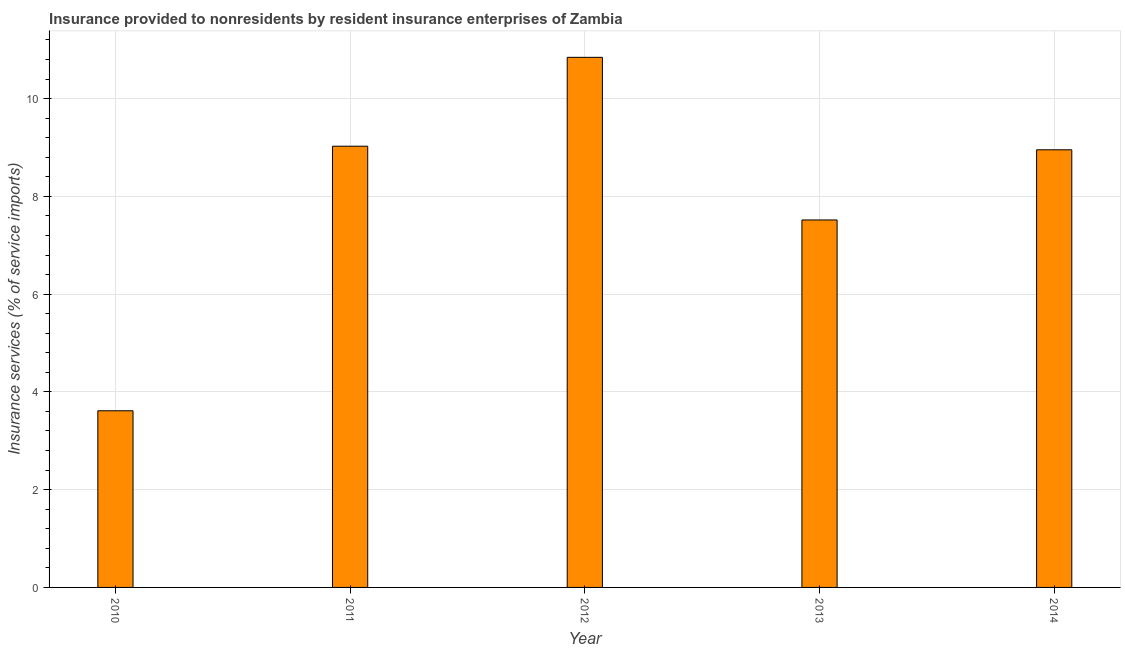Does the graph contain any zero values?
Your answer should be compact. No. Does the graph contain grids?
Ensure brevity in your answer.  Yes. What is the title of the graph?
Ensure brevity in your answer.  Insurance provided to nonresidents by resident insurance enterprises of Zambia. What is the label or title of the Y-axis?
Keep it short and to the point. Insurance services (% of service imports). What is the insurance and financial services in 2014?
Offer a very short reply. 8.95. Across all years, what is the maximum insurance and financial services?
Provide a short and direct response. 10.84. Across all years, what is the minimum insurance and financial services?
Offer a terse response. 3.61. In which year was the insurance and financial services maximum?
Keep it short and to the point. 2012. In which year was the insurance and financial services minimum?
Give a very brief answer. 2010. What is the sum of the insurance and financial services?
Your answer should be compact. 39.95. What is the difference between the insurance and financial services in 2012 and 2014?
Offer a terse response. 1.89. What is the average insurance and financial services per year?
Your response must be concise. 7.99. What is the median insurance and financial services?
Provide a succinct answer. 8.95. In how many years, is the insurance and financial services greater than 0.8 %?
Your answer should be very brief. 5. What is the ratio of the insurance and financial services in 2010 to that in 2011?
Your answer should be compact. 0.4. Is the insurance and financial services in 2010 less than that in 2014?
Offer a terse response. Yes. What is the difference between the highest and the second highest insurance and financial services?
Provide a succinct answer. 1.82. What is the difference between the highest and the lowest insurance and financial services?
Provide a succinct answer. 7.23. How many bars are there?
Your answer should be very brief. 5. Are all the bars in the graph horizontal?
Give a very brief answer. No. What is the Insurance services (% of service imports) in 2010?
Ensure brevity in your answer.  3.61. What is the Insurance services (% of service imports) of 2011?
Make the answer very short. 9.03. What is the Insurance services (% of service imports) in 2012?
Offer a very short reply. 10.84. What is the Insurance services (% of service imports) in 2013?
Offer a terse response. 7.52. What is the Insurance services (% of service imports) in 2014?
Your response must be concise. 8.95. What is the difference between the Insurance services (% of service imports) in 2010 and 2011?
Keep it short and to the point. -5.41. What is the difference between the Insurance services (% of service imports) in 2010 and 2012?
Offer a very short reply. -7.23. What is the difference between the Insurance services (% of service imports) in 2010 and 2013?
Offer a terse response. -3.9. What is the difference between the Insurance services (% of service imports) in 2010 and 2014?
Ensure brevity in your answer.  -5.34. What is the difference between the Insurance services (% of service imports) in 2011 and 2012?
Provide a short and direct response. -1.82. What is the difference between the Insurance services (% of service imports) in 2011 and 2013?
Keep it short and to the point. 1.51. What is the difference between the Insurance services (% of service imports) in 2011 and 2014?
Your response must be concise. 0.07. What is the difference between the Insurance services (% of service imports) in 2012 and 2013?
Make the answer very short. 3.33. What is the difference between the Insurance services (% of service imports) in 2012 and 2014?
Provide a short and direct response. 1.89. What is the difference between the Insurance services (% of service imports) in 2013 and 2014?
Ensure brevity in your answer.  -1.44. What is the ratio of the Insurance services (% of service imports) in 2010 to that in 2011?
Ensure brevity in your answer.  0.4. What is the ratio of the Insurance services (% of service imports) in 2010 to that in 2012?
Your answer should be compact. 0.33. What is the ratio of the Insurance services (% of service imports) in 2010 to that in 2013?
Your answer should be compact. 0.48. What is the ratio of the Insurance services (% of service imports) in 2010 to that in 2014?
Keep it short and to the point. 0.4. What is the ratio of the Insurance services (% of service imports) in 2011 to that in 2012?
Your response must be concise. 0.83. What is the ratio of the Insurance services (% of service imports) in 2011 to that in 2013?
Your response must be concise. 1.2. What is the ratio of the Insurance services (% of service imports) in 2011 to that in 2014?
Provide a succinct answer. 1.01. What is the ratio of the Insurance services (% of service imports) in 2012 to that in 2013?
Offer a very short reply. 1.44. What is the ratio of the Insurance services (% of service imports) in 2012 to that in 2014?
Provide a short and direct response. 1.21. What is the ratio of the Insurance services (% of service imports) in 2013 to that in 2014?
Offer a very short reply. 0.84. 